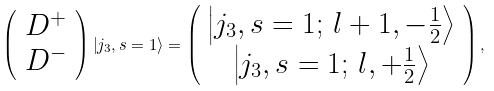<formula> <loc_0><loc_0><loc_500><loc_500>\left ( \begin{array} { c } D ^ { + } \\ D ^ { - } \end{array} \right ) \left | j _ { 3 } , s = 1 \right \rangle = \left ( \begin{array} { c } \left | j _ { 3 } , s = 1 ; \, l + 1 , - \frac { 1 } { 2 } \right \rangle \\ \left | j _ { 3 } , s = 1 ; \, l , + \frac { 1 } { 2 } \right \rangle \end{array} \right ) ,</formula> 